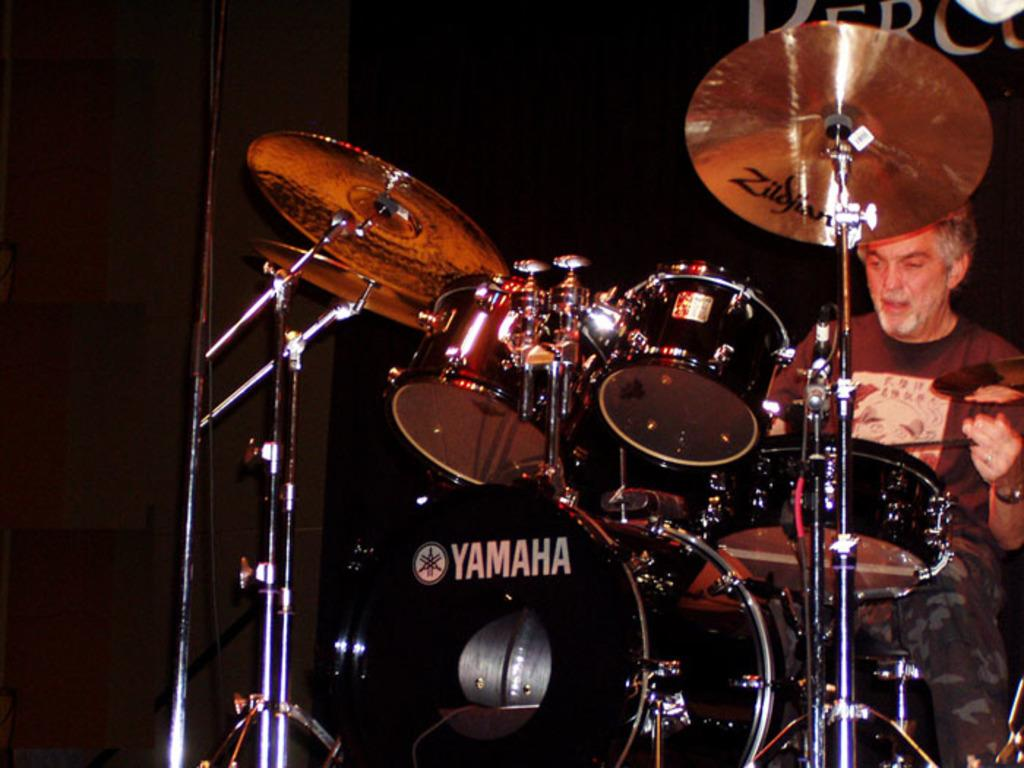What is the person in the image doing? The person is playing musical instruments in the image. Where is the person playing the instruments located? The person is on a stage. What can be seen in the background of the image? There is a wall and text visible in the background. How would you describe the color of the background? The background has a dark color. What type of operation is being performed on the market in the image? There is no operation or market present in the image; it features a person playing musical instruments on a stage with a dark-colored background. Can you see any rays of light in the image? There are no rays of light visible in the image. 